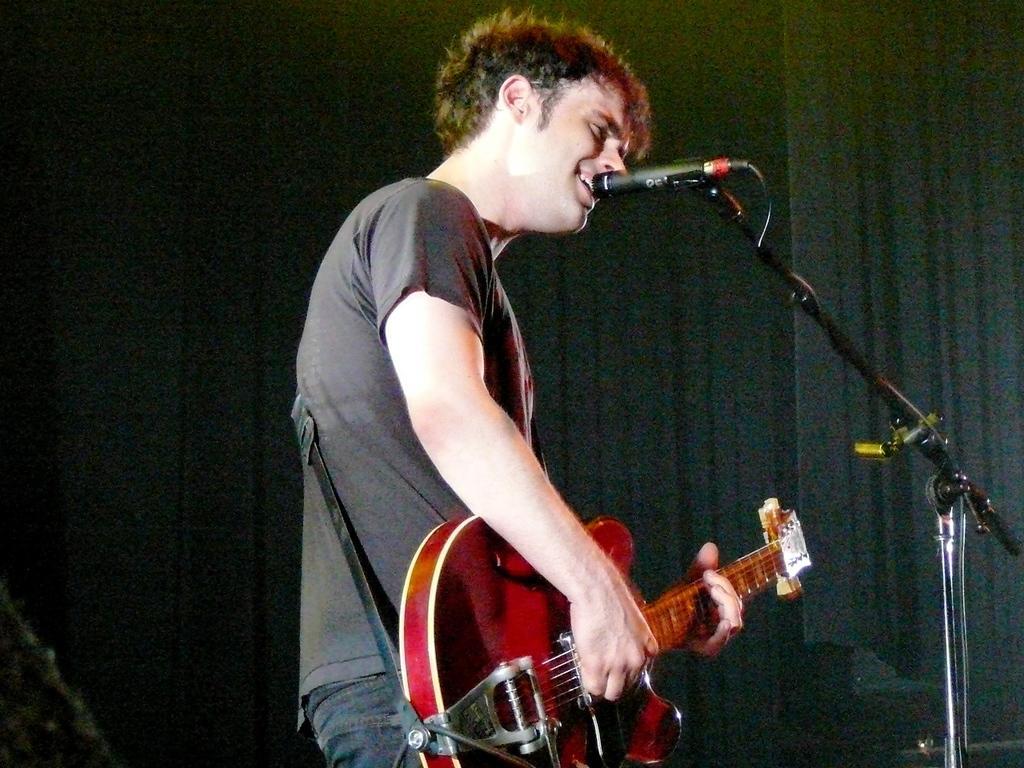Could you give a brief overview of what you see in this image? In this image I can see there is a person standing and playing guitar and singing. And in front of him there is a microphone. 